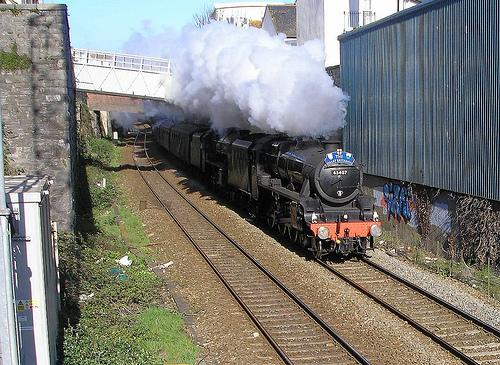Mention some physical attributes of the bridge depicted in the image. The bridge is a white metal overpass which is above the train tracks, covering a long length. In the scene, which objects are near the train tracks and what is their appearance? There are white houses next to the tracks, green grass and vines, and a gray stone wall near the train tracks. What type of artwork is present in the image and where is it located? There is graffiti, specifically black and blue graffiti, on a blue metal wall next to the tracks. What is the interaction between the train and its environment in this image? The train is moving along the tracks, generating white smoke from its stack, and passing by various objects such as a bridge, grass, and graffiti. Give an overview of the area surrounding the train tracks and the objects present. The area has a gray stone wall, green grass and vines, trash, and a blue metal wall with graffiti near the train tracks. Describe the graffiti found in the image, including its color and location. The graffiti is black and blue and is on a blue metal wall near the train tracks. What is a distinctive feature of the train in the image and the substance coming from it? The train has an orange and mostly black color, and white smoke is coming from its stack. What are some details of the train tracks and their condition in the image? The train tracks are black copper and have grass, weeds, and trash along them. Identify the color of the steam engine and what it is doing in the image. The steam engine is black and it is pulling cars, releasing steam from its funnel. How many sets of train tracks are visible in the image and describe their condition? There are two sets of train tracks; one has a moving train on it, while the other is empty and both have some trash, grass, and weeds along them. Describe the interaction between the train smoke and other objects in the image. The train smoke billows upwards and interacts with the air, creating an atmospheric effect above the train and near the bridge and houses. Determine if there is grass near the train tracks. Yes, there is green grass and vines near the train tracks. Locate the trash along the train tracks. X:98 Y:176 Width:131 Height:131 How many train tracks can be seen in the image? Two sets of train tracks are visible. Evaluate the quality of the image. The image quality is acceptable with clear details on the objects and good composition. List the colors of the train cars. black, orange, blue Describe the wall which has graffiti on it. The wall is a blue metal wall with black and blue graffiti. How many lights are on the front of the train? There are two round lights on the front of the train. Find the object and its location in the image based on the caption "greyish white brick wall". X:31 Y:41 Width:56 Height:56 Describe the scene in the image. A steam train with white smoke billowing from its stack is moving along train tracks with a white bridge, stone wall, and graffiti-covered blue wall nearby. Identify any anomalies in the image. Graffiti on the blue wall may be considered an anomaly as it is defacing the otherwise clean and structured scene. Locate the train stack and identify its color. The train stack is located at X:320 Y:127 Width:24 Height:24, and it is black. Identify the location of the orange part of the train car. X:275 Y:130 Width:132 Height:132 List the objects found in the image. steam funnel, black steam engine, train tracks, stone wall, white bridge, blue wall, graffiti, white houses, green grass, rail, fence, white smoke, orange and black train, train lights, train numbers, train stack, pitched roof, power source, brick wall, trash, weeds, building. Read the blue writing on the sign and give its location. Blue graffiti, located at X:367 Y:180 Width:72 Height:72 What emotions does the image evoke? The image evokes a feeling of nostalgia and intrigue due to the old steam engine and the surrounding environment. What is the white structure over the train tracks? a white metal bridge Are there any houses visible in the image? Yes, there are some white houses next to the track. Describe the fencing seen in the image. There is a section of the fence on the edge with a white power source nearby. What can be seen near the stone wall? The stone wall is near the train tracks, a white overpass, and a power source. 